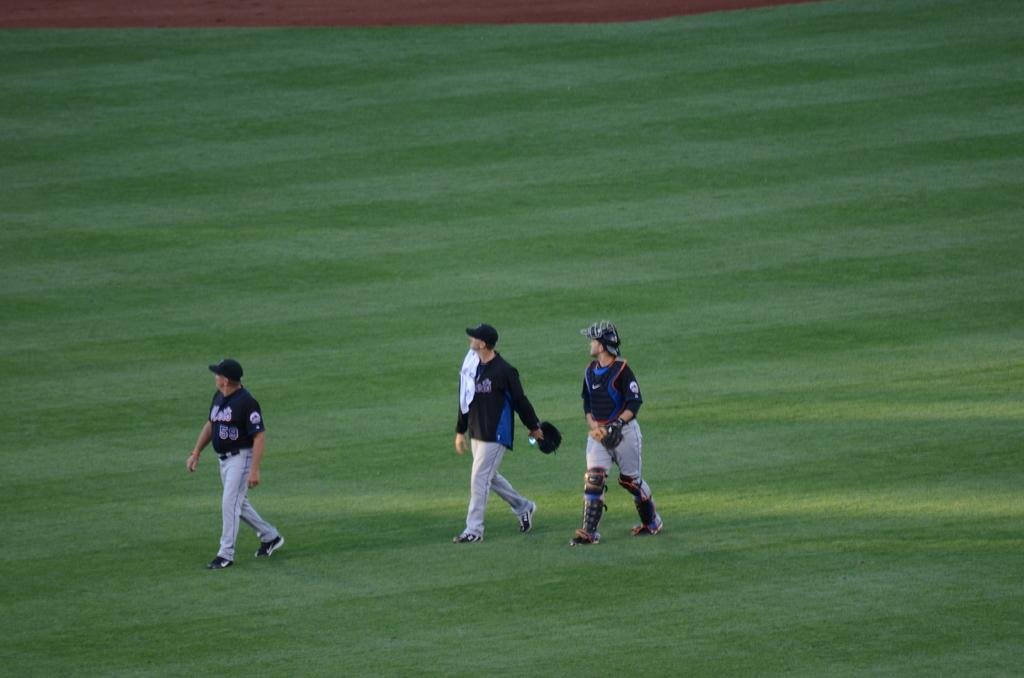How many people are in the image? There are three persons in the image. What are the persons doing in the image? The persons are walking. What type of vegetation can be seen in the image? The grass is visible in the image. What type of bells can be heard ringing in the image? There are no bells present in the image, and therefore no sound can be heard. 